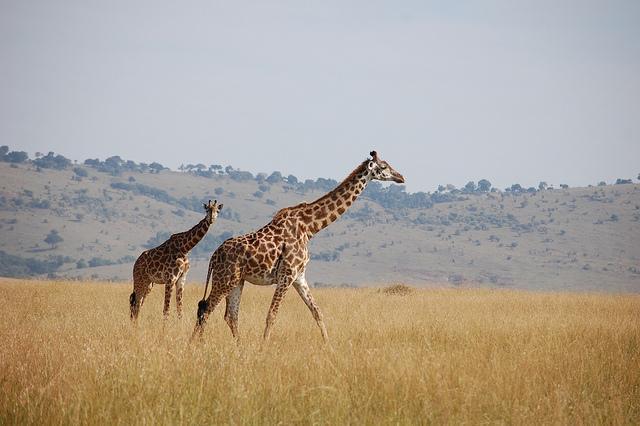How many animals are shown?
Give a very brief answer. 2. How many giraffe are there?
Give a very brief answer. 2. How many giraffes are there?
Give a very brief answer. 2. How many people are on blue skis?
Give a very brief answer. 0. 